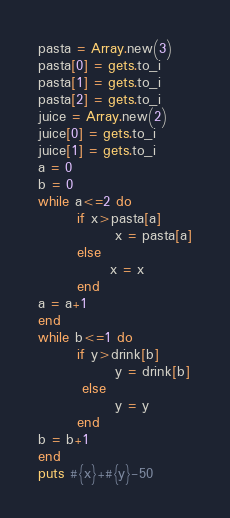Convert code to text. <code><loc_0><loc_0><loc_500><loc_500><_Ruby_>pasta = Array.new(3)
pasta[0] = gets.to_i
pasta[1] = gets.to_i
pasta[2] = gets.to_i
juice = Array.new(2)
juice[0] = gets.to_i
juice[1] = gets.to_i
a = 0
b = 0
while a<=2 do
       if x>pasta[a]
              x = pasta[a]
       else
             x = x
       end
a = a+1
end
while b<=1 do
       if y>drink[b]
              y = drink[b]
        else
              y = y
       end
b = b+1
end
puts #{x}+#{y}-50</code> 